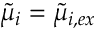Convert formula to latex. <formula><loc_0><loc_0><loc_500><loc_500>\tilde { \mu } _ { i } = \tilde { \mu } _ { i , e x }</formula> 